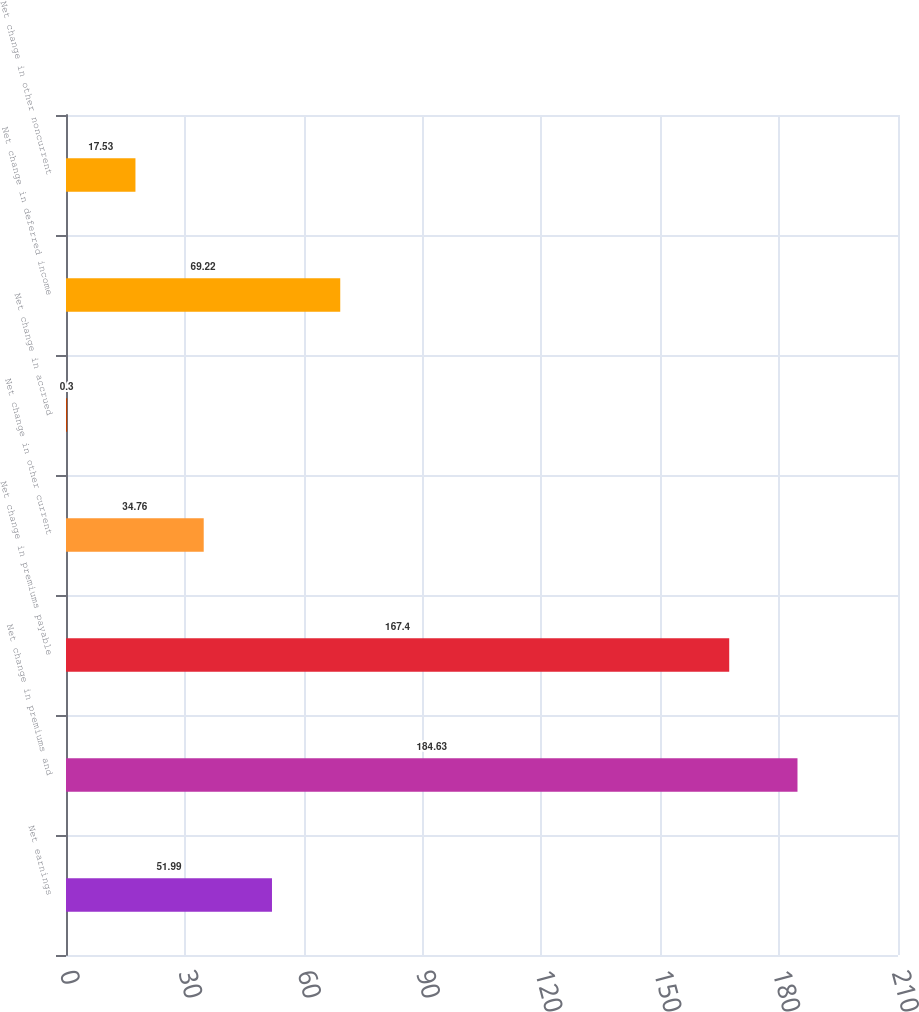<chart> <loc_0><loc_0><loc_500><loc_500><bar_chart><fcel>Net earnings<fcel>Net change in premiums and<fcel>Net change in premiums payable<fcel>Net change in other current<fcel>Net change in accrued<fcel>Net change in deferred income<fcel>Net change in other noncurrent<nl><fcel>51.99<fcel>184.63<fcel>167.4<fcel>34.76<fcel>0.3<fcel>69.22<fcel>17.53<nl></chart> 